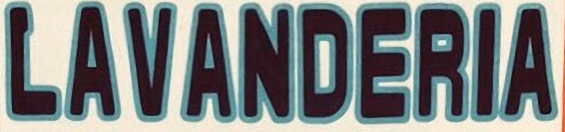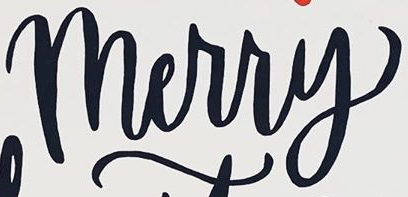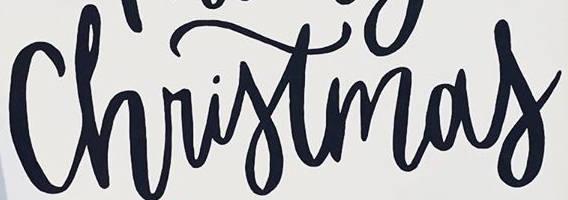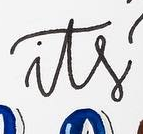What words are shown in these images in order, separated by a semicolon? LAVANDERIA; Merry; Christmas; its 